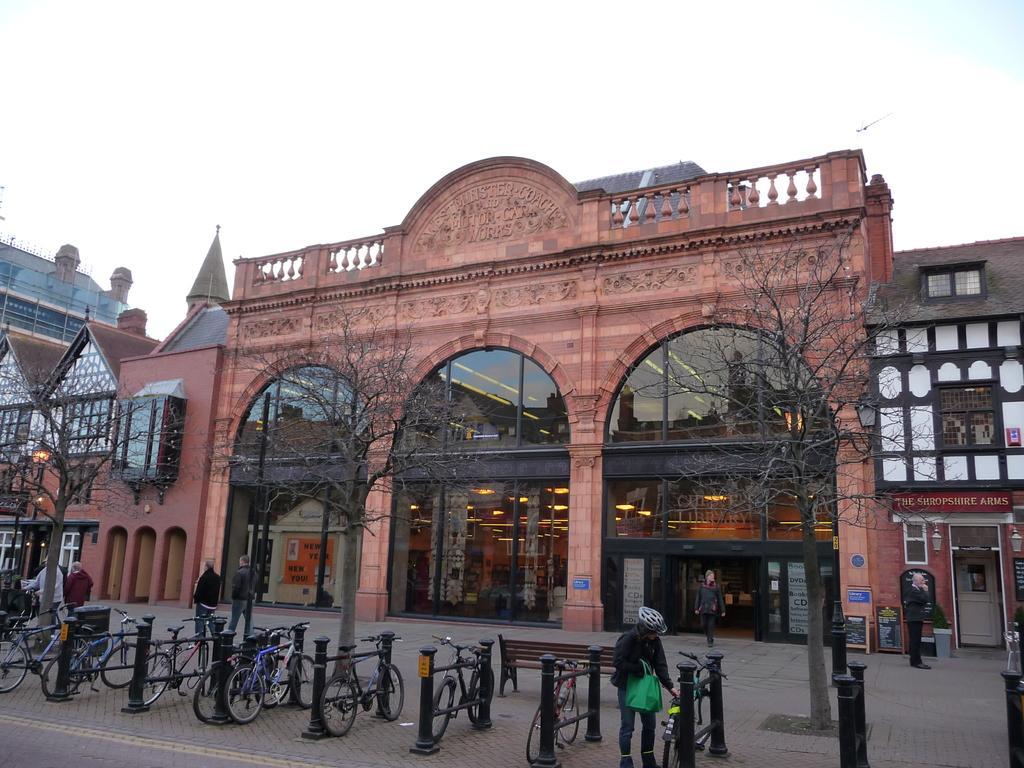How would you summarize this image in a sentence or two? In this image we can see some persons walking through the footpath there are some bicycles which are parked there are some poles and trees and in the background of the image there are some buildings and top of the image there is clear sky. 